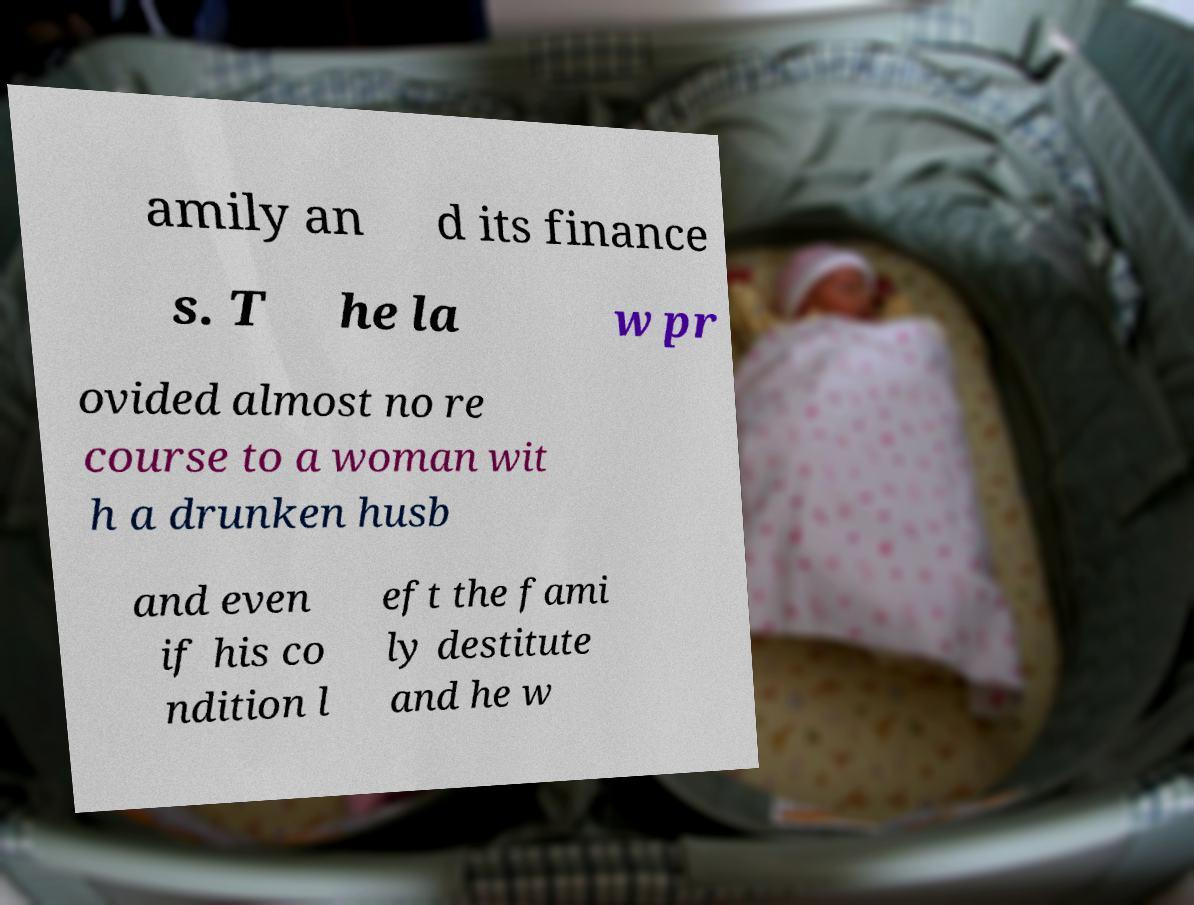Can you read and provide the text displayed in the image?This photo seems to have some interesting text. Can you extract and type it out for me? amily an d its finance s. T he la w pr ovided almost no re course to a woman wit h a drunken husb and even if his co ndition l eft the fami ly destitute and he w 